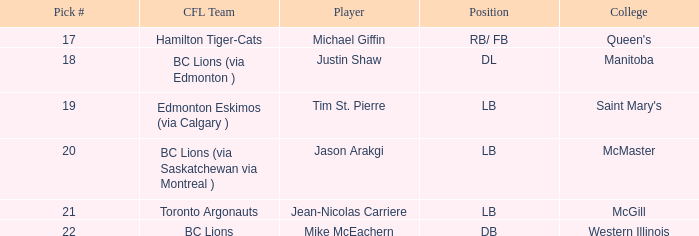Can you give me this table as a dict? {'header': ['Pick #', 'CFL Team', 'Player', 'Position', 'College'], 'rows': [['17', 'Hamilton Tiger-Cats', 'Michael Giffin', 'RB/ FB', "Queen's"], ['18', 'BC Lions (via Edmonton )', 'Justin Shaw', 'DL', 'Manitoba'], ['19', 'Edmonton Eskimos (via Calgary )', 'Tim St. Pierre', 'LB', "Saint Mary's"], ['20', 'BC Lions (via Saskatchewan via Montreal )', 'Jason Arakgi', 'LB', 'McMaster'], ['21', 'Toronto Argonauts', 'Jean-Nicolas Carriere', 'LB', 'McGill'], ['22', 'BC Lions', 'Mike McEachern', 'DB', 'Western Illinois']]} How many pick numbers did Michael Giffin have? 1.0. 